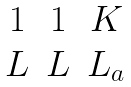<formula> <loc_0><loc_0><loc_500><loc_500>\begin{matrix} 1 & 1 & K \\ L & L & L _ { a } \end{matrix}</formula> 